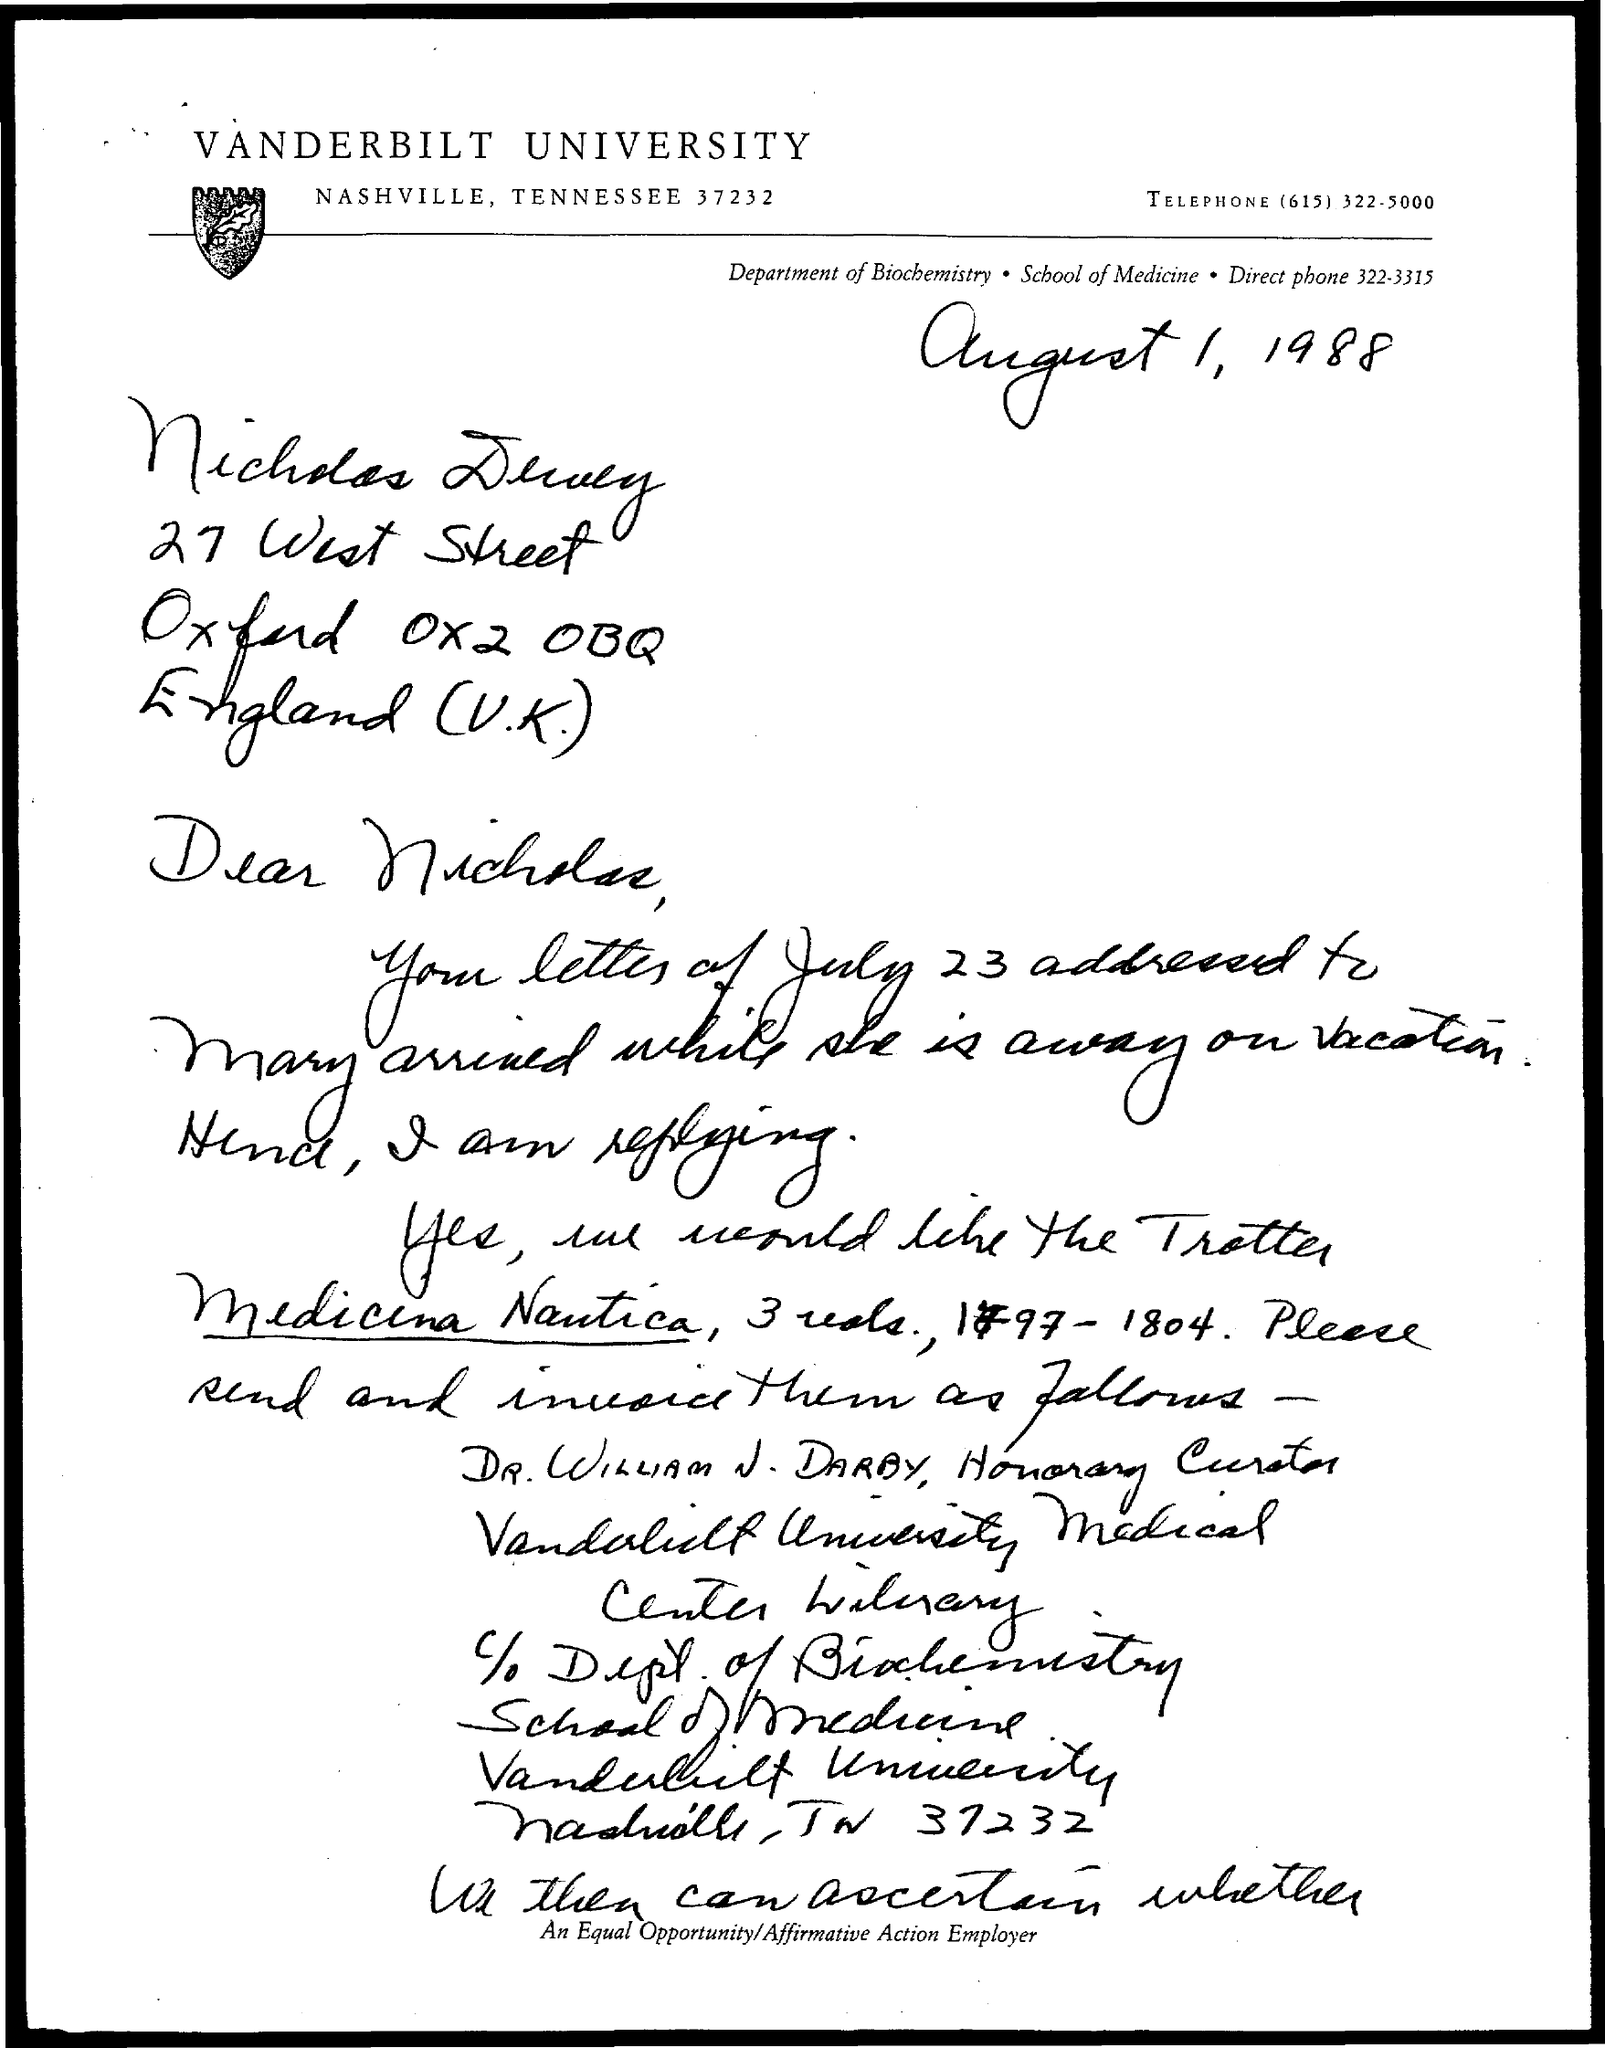What is the name of the university?
Provide a short and direct response. Vanderbilt University. What is the telephone number?
Offer a very short reply. (615) 322-5000. What is the date mentioned in the document?
Keep it short and to the point. August 1, 1988. 